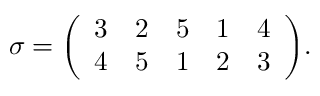<formula> <loc_0><loc_0><loc_500><loc_500>\sigma = { \left ( \begin{array} { l l l l l } { 3 } & { 2 } & { 5 } & { 1 } & { 4 } \\ { 4 } & { 5 } & { 1 } & { 2 } & { 3 } \end{array} \right ) } .</formula> 